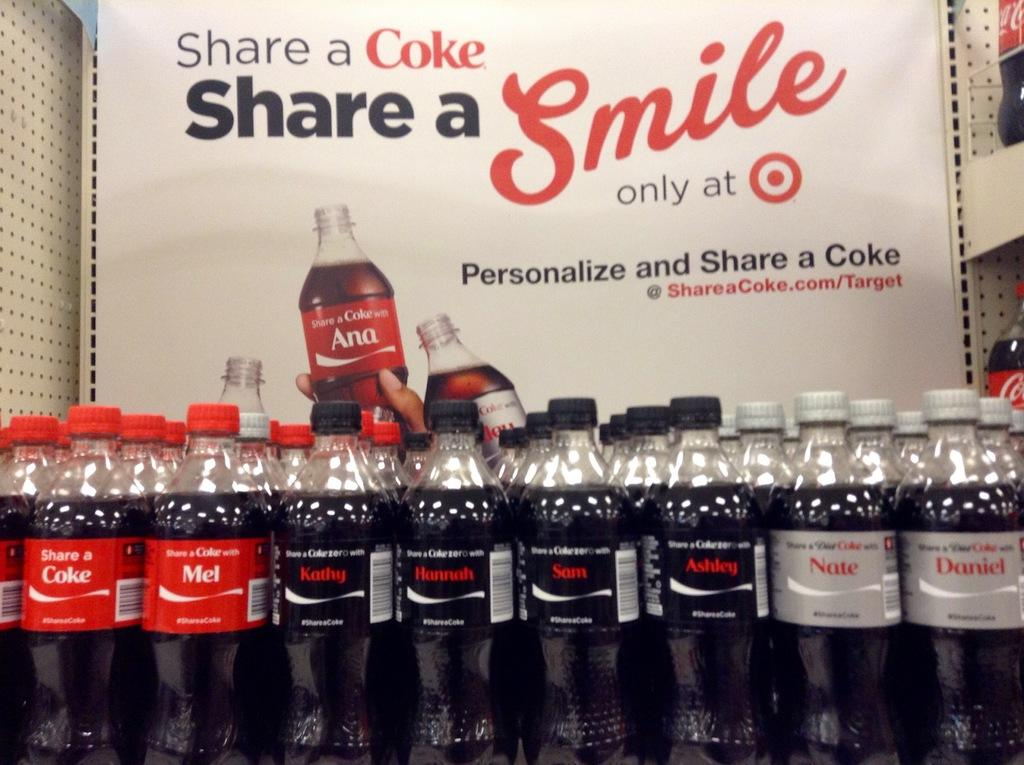<image>
Relay a brief, clear account of the picture shown. A display set up for Coke saying to share and personalize. 